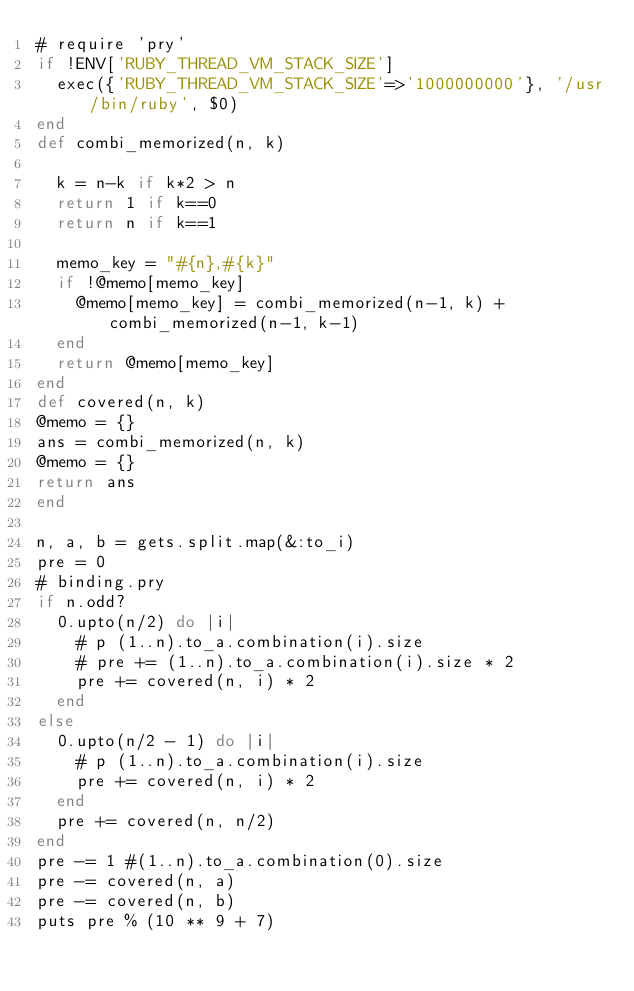<code> <loc_0><loc_0><loc_500><loc_500><_Ruby_># require 'pry'
if !ENV['RUBY_THREAD_VM_STACK_SIZE']
  exec({'RUBY_THREAD_VM_STACK_SIZE'=>'1000000000'}, '/usr/bin/ruby', $0)
end
def combi_memorized(n, k)

  k = n-k if k*2 > n
  return 1 if k==0
  return n if k==1

  memo_key = "#{n},#{k}"
  if !@memo[memo_key]
    @memo[memo_key] = combi_memorized(n-1, k) + combi_memorized(n-1, k-1)
  end
  return @memo[memo_key]
end
def covered(n, k)
@memo = {}
ans = combi_memorized(n, k)
@memo = {}
return ans
end

n, a, b = gets.split.map(&:to_i)
pre = 0
# binding.pry
if n.odd?
  0.upto(n/2) do |i|
    # p (1..n).to_a.combination(i).size
    # pre += (1..n).to_a.combination(i).size * 2
    pre += covered(n, i) * 2
  end
else
  0.upto(n/2 - 1) do |i|
    # p (1..n).to_a.combination(i).size
    pre += covered(n, i) * 2
  end
  pre += covered(n, n/2)
end
pre -= 1 #(1..n).to_a.combination(0).size
pre -= covered(n, a)
pre -= covered(n, b)
puts pre % (10 ** 9 + 7)
</code> 